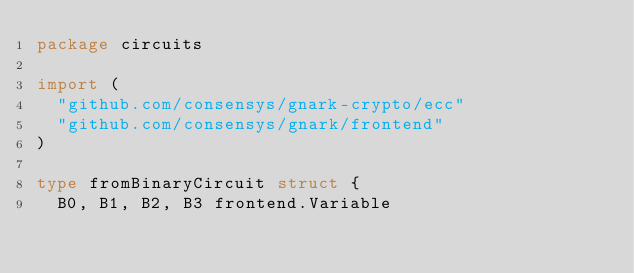<code> <loc_0><loc_0><loc_500><loc_500><_Go_>package circuits

import (
	"github.com/consensys/gnark-crypto/ecc"
	"github.com/consensys/gnark/frontend"
)

type fromBinaryCircuit struct {
	B0, B1, B2, B3 frontend.Variable</code> 